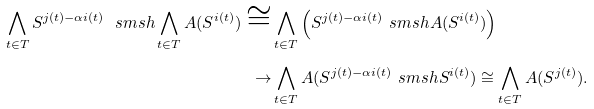Convert formula to latex. <formula><loc_0><loc_0><loc_500><loc_500>\bigwedge _ { t \in T } S ^ { j ( t ) - \alpha i ( t ) } \ s m s h \bigwedge _ { t \in T } A ( S ^ { i ( t ) } ) \cong & \bigwedge _ { t \in T } \left ( S ^ { j ( t ) - \alpha i ( t ) } \ s m s h A ( S ^ { i ( t ) } ) \right ) \\ \to & \bigwedge _ { t \in T } A ( S ^ { j ( t ) - \alpha i ( t ) } \ s m s h S ^ { i ( t ) } ) \cong \bigwedge _ { t \in T } A ( S ^ { j ( t ) } ) .</formula> 